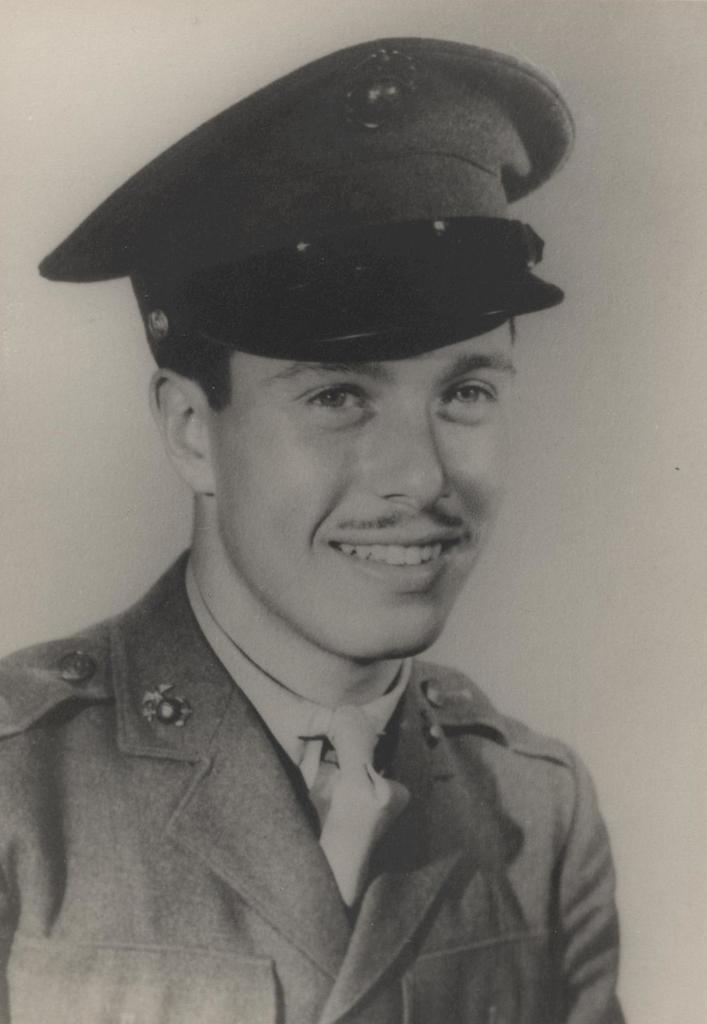What is the color scheme of the image? The image is black and white. Who is present in the image? There is a man in the image. What is the man wearing on his head? The man is wearing a cap. What is the man's facial expression in the image? The man is smiling. What type of drum can be seen in the man's eye in the image? There is no drum visible in the man's eye in the image. 